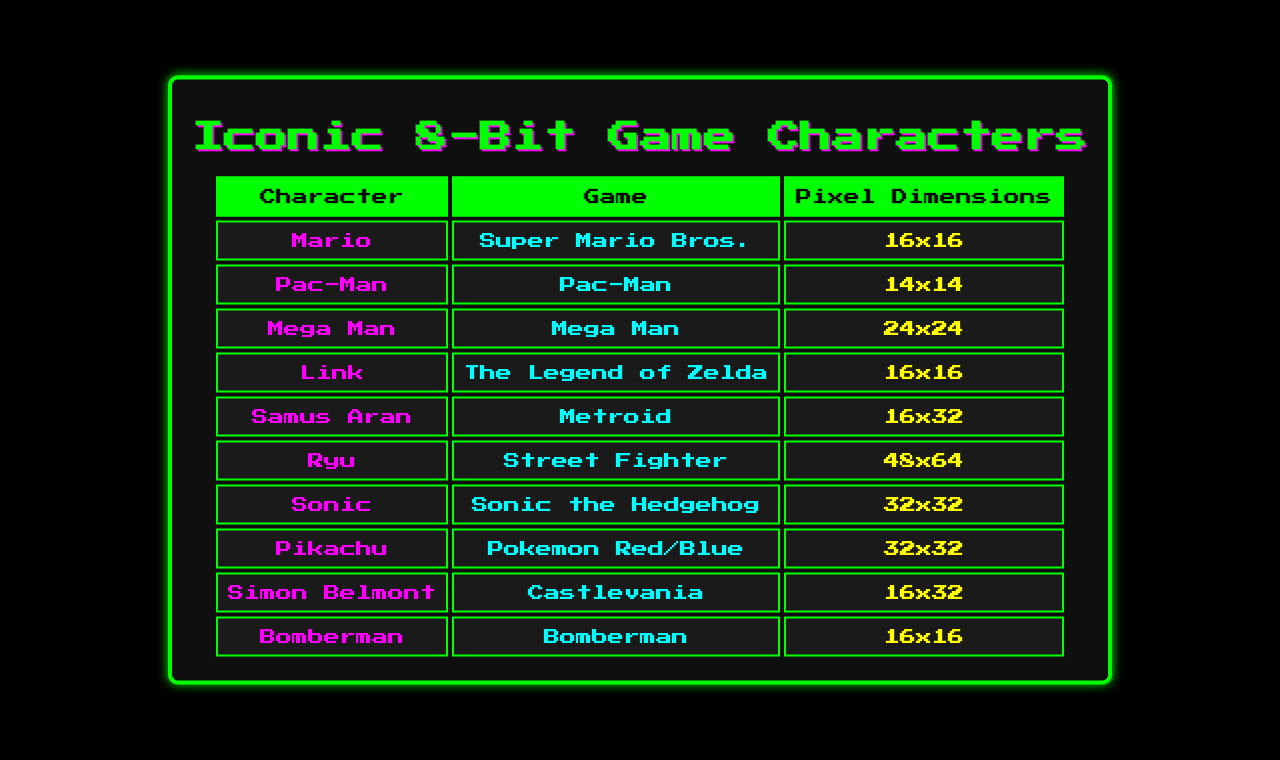What are the pixel dimensions of Samus Aran? The table lists Samus Aran's pixel dimensions as 16x32.
Answer: 16x32 Which character has the largest width? By examining the width column, Ryu has the largest width at 48 pixels.
Answer: 48 How many characters have the same height as Mario? Mario's height is 16 pixels. Reviewing the table, Bomberman and Link also have a height of 16 pixels, making a total of 3 characters.
Answer: 3 Is Sonic taller than Mega Man? Sonic has a height of 32 pixels, while Mega Man is 24 pixels tall. Since 32 is greater than 24, Sonic is indeed taller.
Answer: Yes What is the total height of all characters combined? The heights of the characters are: 16 + 14 + 24 + 16 + 32 + 64 + 32 + 32 + 32 + 16 = 288. Thus, the total height is 288 pixels.
Answer: 288 Which character represents a pixel size equal to Pac-Man? Pac-Man has pixel dimensions of 14x14. After checking the table, no other character has the same dimensions, so the answer is none.
Answer: None If you average the widths of all characters in the table, what is the result? The widths are: 16 + 14 + 24 + 16 + 16 + 48 + 32 + 32 + 16 + 16 = 288. There are 10 characters, thus averaging gives 288/10 = 28.8.
Answer: 28.8 Which characters are from games with pixel heights equal to or greater than 32? Looking at the height column, Samus Aran, Ryu, and Simon Belmont have heights equal to or greater than 32 pixels, making this a total of 3 characters.
Answer: 3 Which character's width is exactly twice Mario's width? Mario's width is 16 pixels; twice that is 32 pixels. Both Sonic and Pikachu have a width of 32 pixels, fitting the criteria.
Answer: Sonic and Pikachu Is Pam-Man the only character with a height of 14? The only character listed with a height of 14 pixels is Pac-Man. Thus, he is the only one with that height.
Answer: Yes 